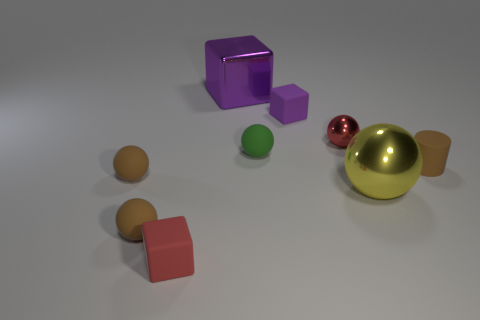Subtract 2 balls. How many balls are left? 3 Subtract all green spheres. How many spheres are left? 4 Subtract all yellow balls. How many balls are left? 4 Subtract all cyan spheres. Subtract all purple cylinders. How many spheres are left? 5 Add 1 red rubber objects. How many objects exist? 10 Subtract all balls. How many objects are left? 4 Add 9 green rubber things. How many green rubber things exist? 10 Subtract 1 red spheres. How many objects are left? 8 Subtract all small brown matte cylinders. Subtract all tiny objects. How many objects are left? 1 Add 9 big yellow metallic balls. How many big yellow metallic balls are left? 10 